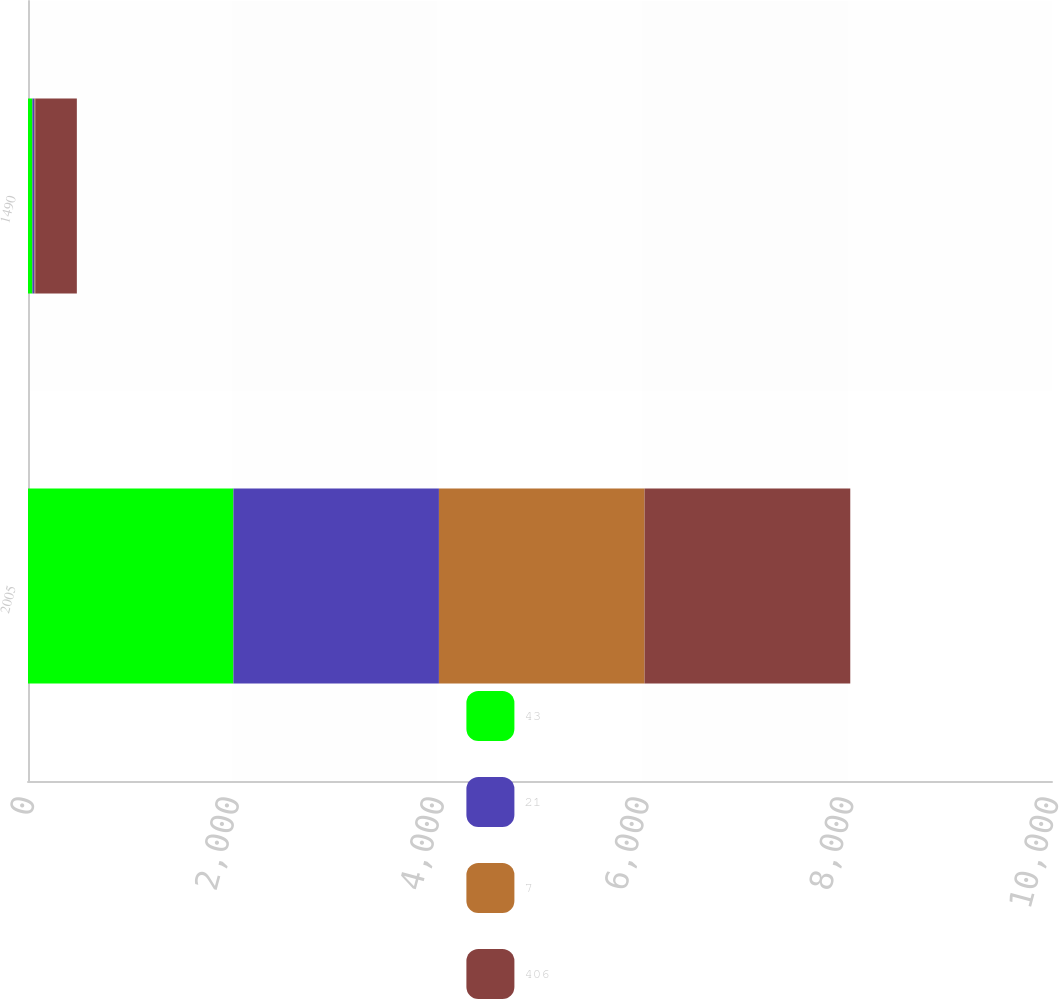Convert chart. <chart><loc_0><loc_0><loc_500><loc_500><stacked_bar_chart><ecel><fcel>2005<fcel>1490<nl><fcel>43<fcel>2006<fcel>43<nl><fcel>21<fcel>2007<fcel>21<nl><fcel>7<fcel>2008<fcel>7<nl><fcel>406<fcel>2009<fcel>406<nl></chart> 